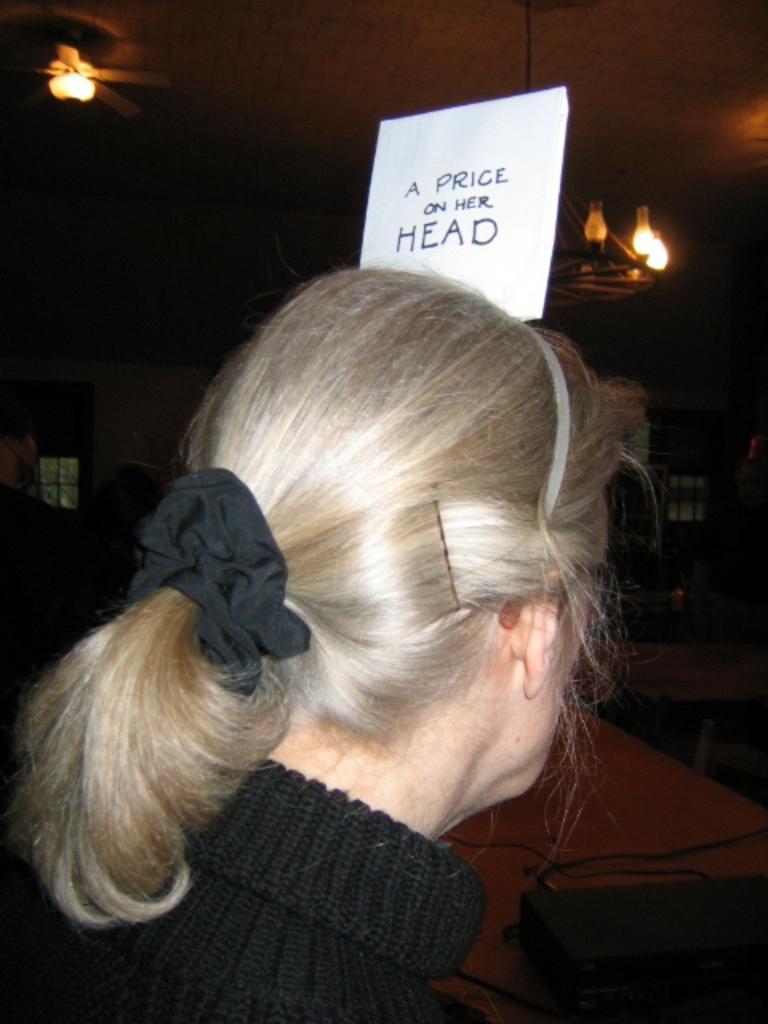Can you describe this image briefly? At the top we can see ceiling and lights. Here we can see a woman wearing a black wool sweater. We can see a black band, hair pin and a white hair band on her hair. This is a paper note. 